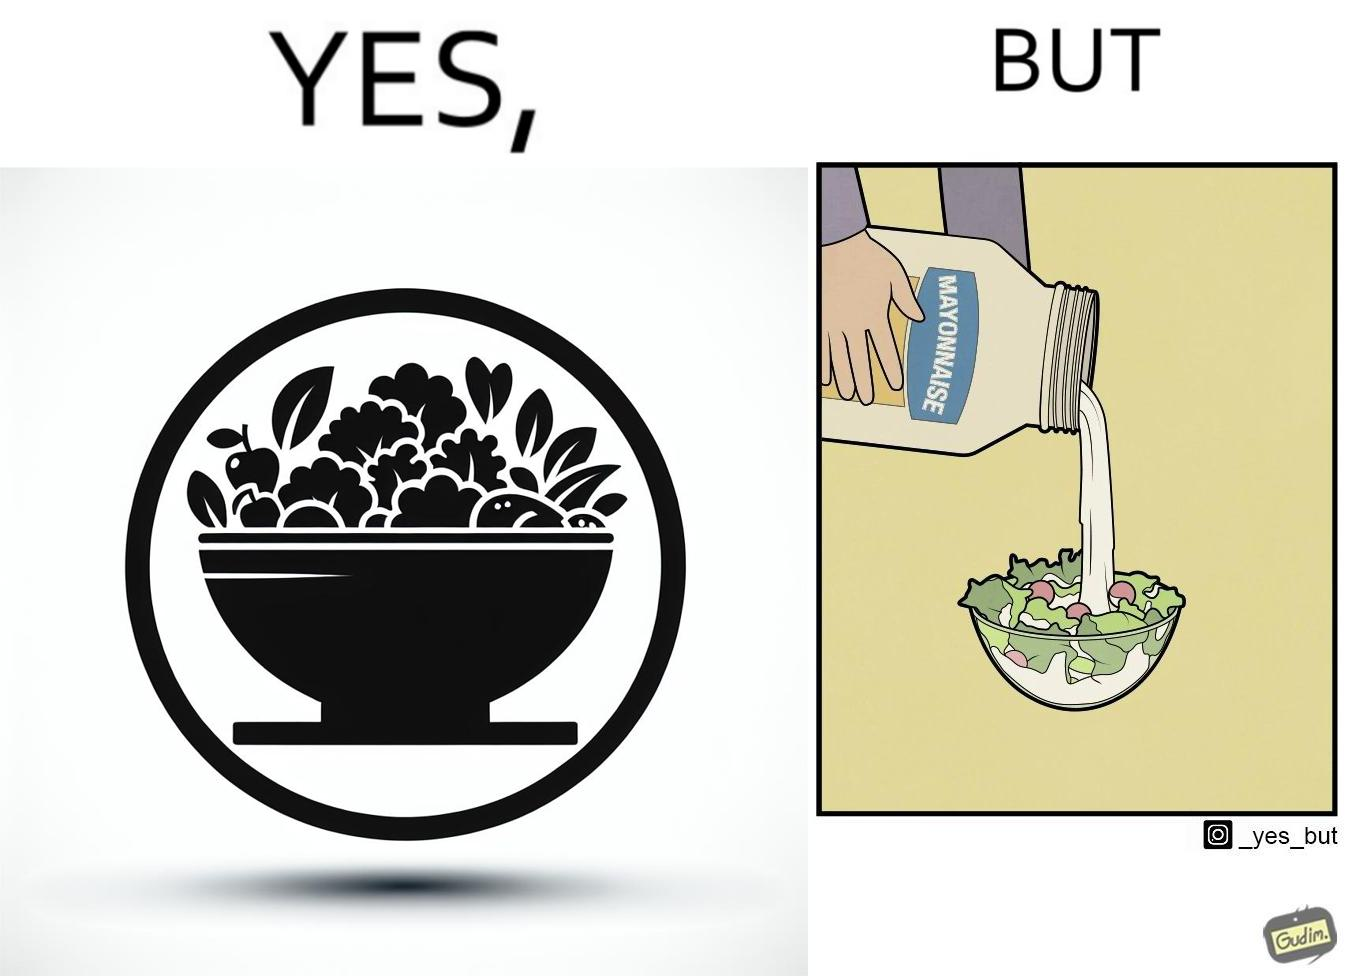Explain the humor or irony in this image. The image is ironical, as salad in a bowl by itself is very healthy. However, when people have it with Mayonnaise sauce to improve the taste, it is not healthy anymore, and defeats the point of having nutrient-rich salad altogether. 